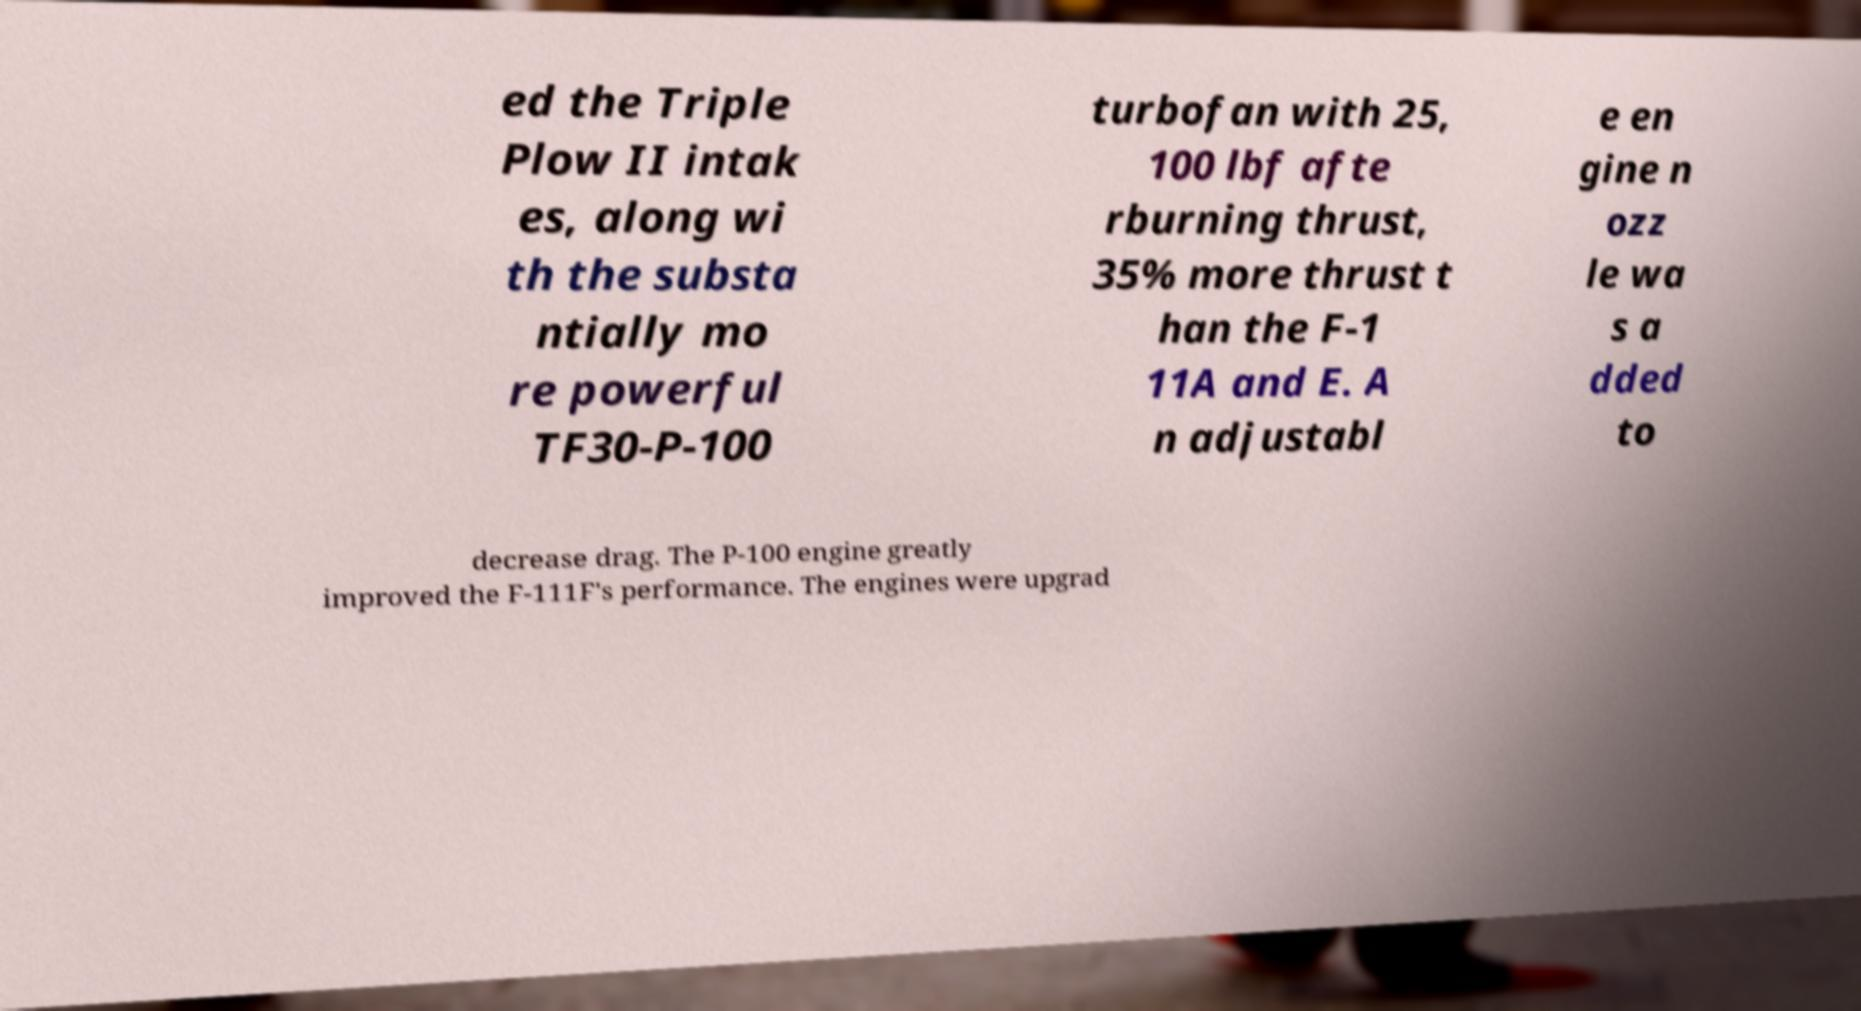Can you read and provide the text displayed in the image?This photo seems to have some interesting text. Can you extract and type it out for me? ed the Triple Plow II intak es, along wi th the substa ntially mo re powerful TF30-P-100 turbofan with 25, 100 lbf afte rburning thrust, 35% more thrust t han the F-1 11A and E. A n adjustabl e en gine n ozz le wa s a dded to decrease drag. The P-100 engine greatly improved the F-111F's performance. The engines were upgrad 